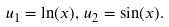<formula> <loc_0><loc_0><loc_500><loc_500>u _ { 1 } = \ln ( x ) , \, u _ { 2 } = \sin ( x ) .</formula> 